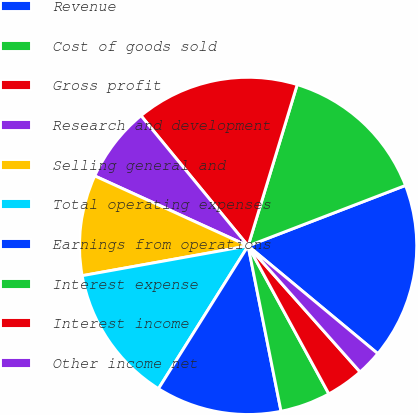Convert chart to OTSL. <chart><loc_0><loc_0><loc_500><loc_500><pie_chart><fcel>Revenue<fcel>Cost of goods sold<fcel>Gross profit<fcel>Research and development<fcel>Selling general and<fcel>Total operating expenses<fcel>Earnings from operations<fcel>Interest expense<fcel>Interest income<fcel>Other income net<nl><fcel>16.87%<fcel>14.46%<fcel>15.66%<fcel>7.23%<fcel>9.64%<fcel>13.25%<fcel>12.05%<fcel>4.82%<fcel>3.61%<fcel>2.41%<nl></chart> 